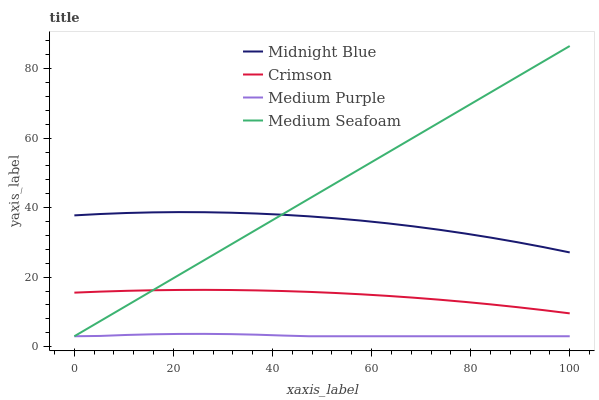Does Medium Purple have the minimum area under the curve?
Answer yes or no. Yes. Does Medium Seafoam have the maximum area under the curve?
Answer yes or no. Yes. Does Midnight Blue have the minimum area under the curve?
Answer yes or no. No. Does Midnight Blue have the maximum area under the curve?
Answer yes or no. No. Is Medium Seafoam the smoothest?
Answer yes or no. Yes. Is Midnight Blue the roughest?
Answer yes or no. Yes. Is Medium Purple the smoothest?
Answer yes or no. No. Is Medium Purple the roughest?
Answer yes or no. No. Does Medium Purple have the lowest value?
Answer yes or no. Yes. Does Midnight Blue have the lowest value?
Answer yes or no. No. Does Medium Seafoam have the highest value?
Answer yes or no. Yes. Does Midnight Blue have the highest value?
Answer yes or no. No. Is Medium Purple less than Midnight Blue?
Answer yes or no. Yes. Is Midnight Blue greater than Medium Purple?
Answer yes or no. Yes. Does Medium Seafoam intersect Crimson?
Answer yes or no. Yes. Is Medium Seafoam less than Crimson?
Answer yes or no. No. Is Medium Seafoam greater than Crimson?
Answer yes or no. No. Does Medium Purple intersect Midnight Blue?
Answer yes or no. No. 